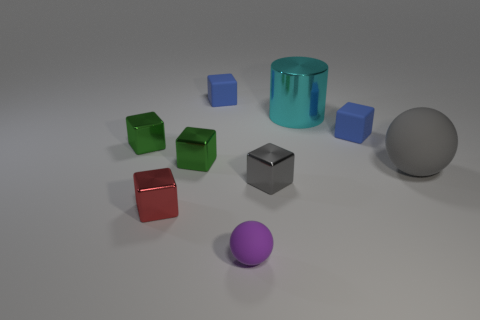Are there any other things that are made of the same material as the red cube?
Make the answer very short. Yes. There is a metal object that is the same color as the big sphere; what shape is it?
Offer a terse response. Cube. How many cylinders are either blue matte things or gray shiny objects?
Provide a succinct answer. 0. There is a rubber block behind the tiny rubber thing that is to the right of the large cyan cylinder; what is its color?
Provide a succinct answer. Blue. There is a tiny sphere; is it the same color as the metal cube that is to the left of the red metallic thing?
Your response must be concise. No. There is a gray thing that is the same material as the large cyan thing; what size is it?
Keep it short and to the point. Small. What size is the thing that is the same color as the big sphere?
Your answer should be very brief. Small. Does the large matte object have the same color as the large shiny thing?
Your answer should be very brief. No. There is a blue matte thing on the right side of the blue matte thing that is to the left of the purple rubber object; are there any tiny gray objects behind it?
Your response must be concise. No. How many cyan metal cylinders are the same size as the gray cube?
Make the answer very short. 0. 